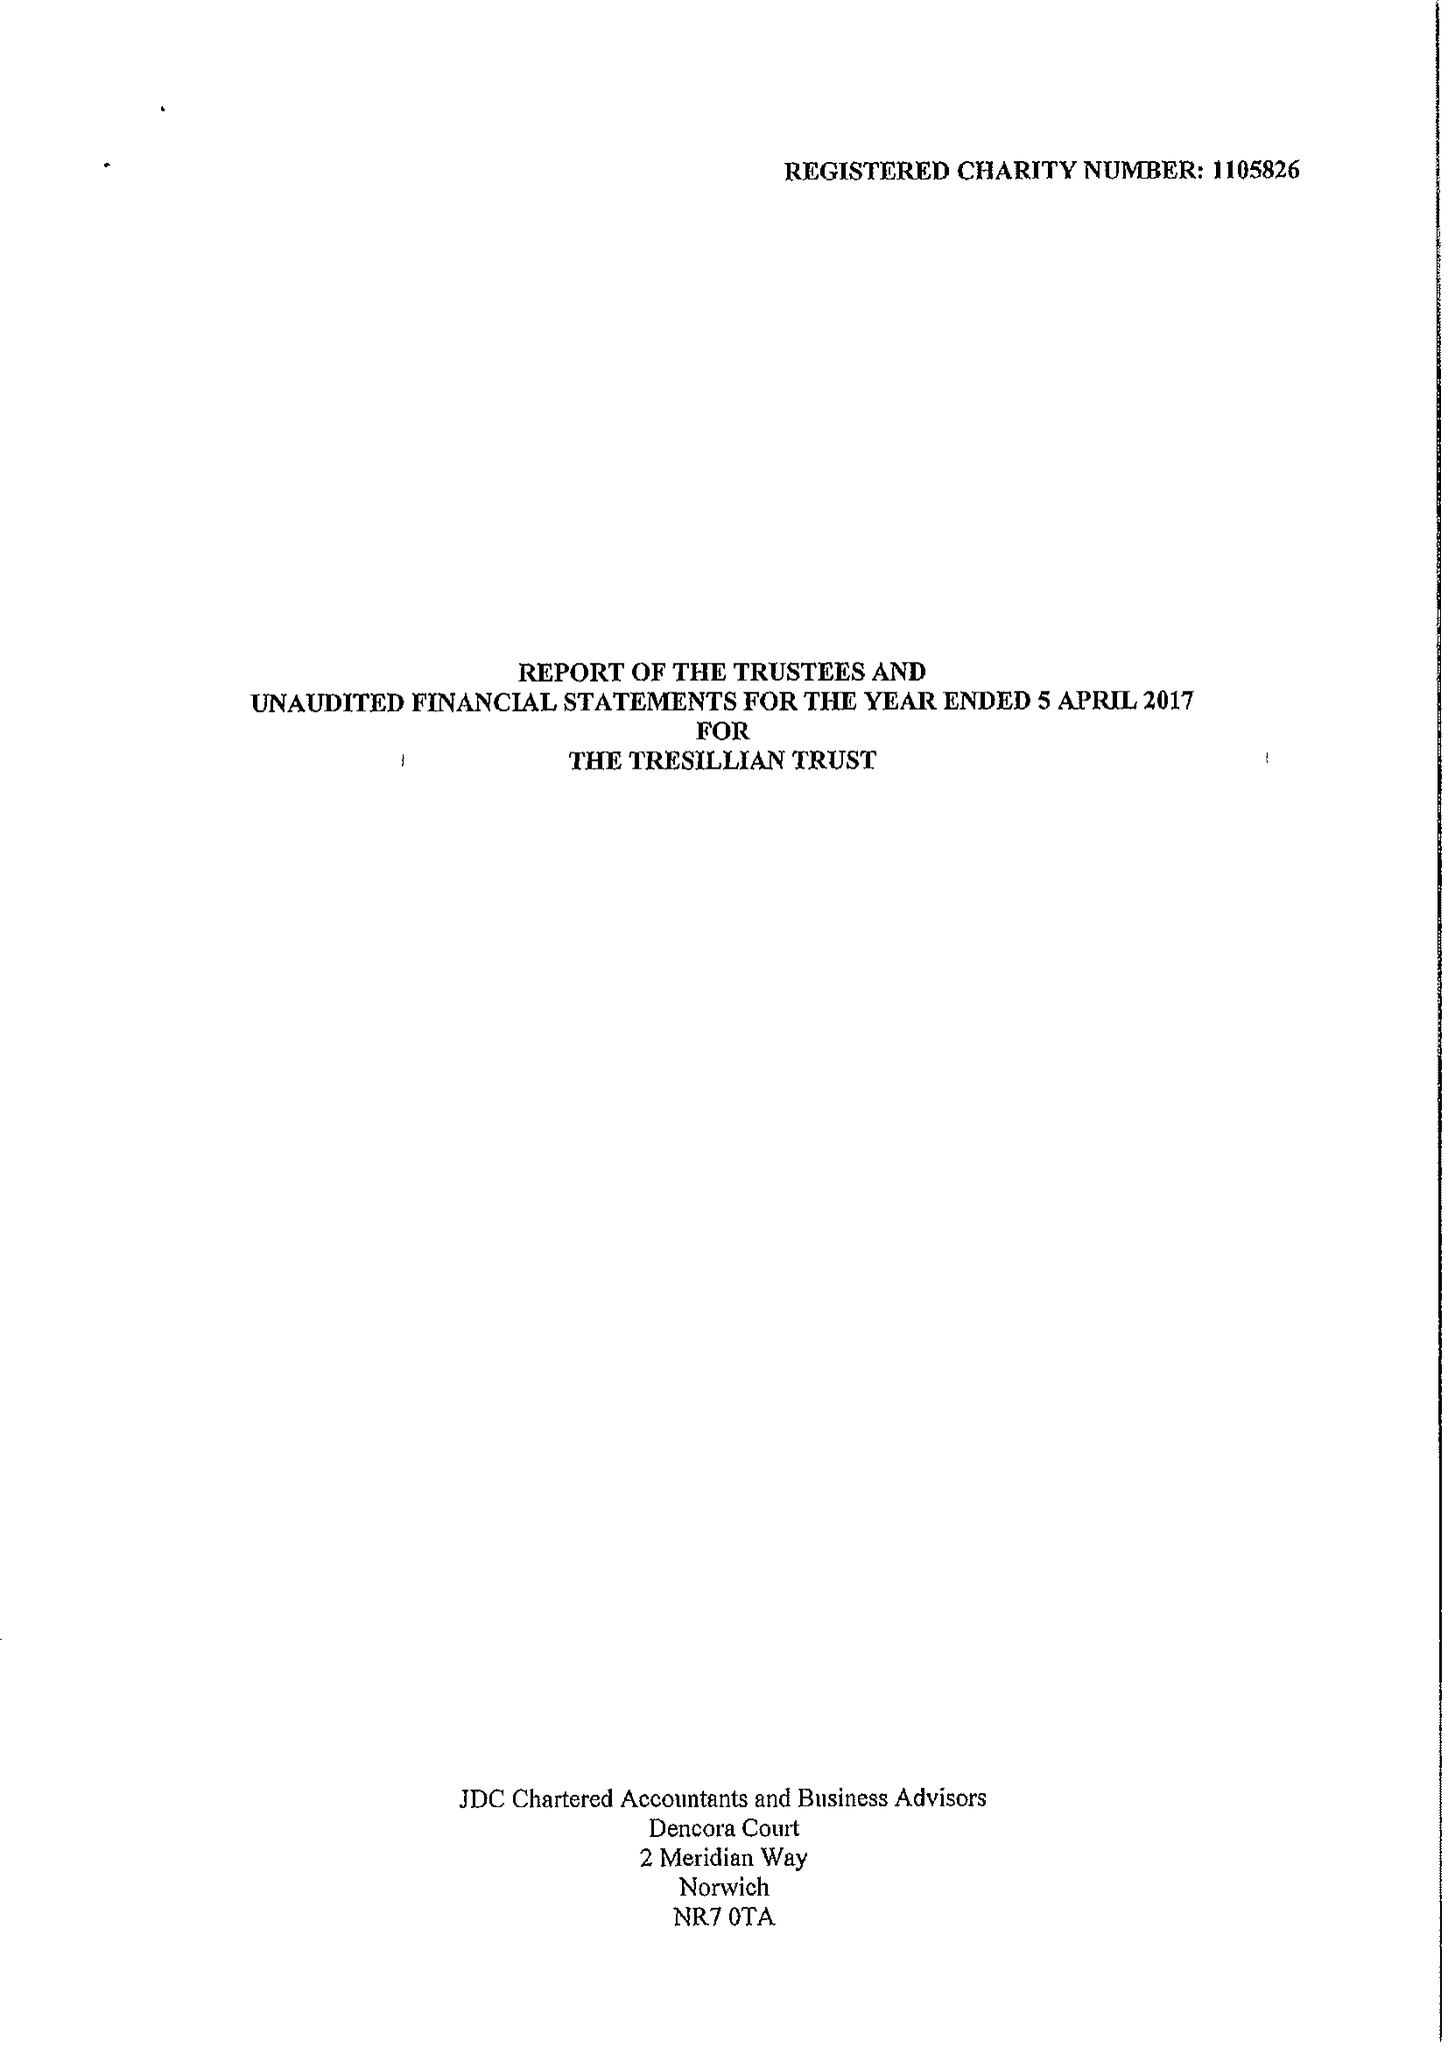What is the value for the income_annually_in_british_pounds?
Answer the question using a single word or phrase. 128607.00 